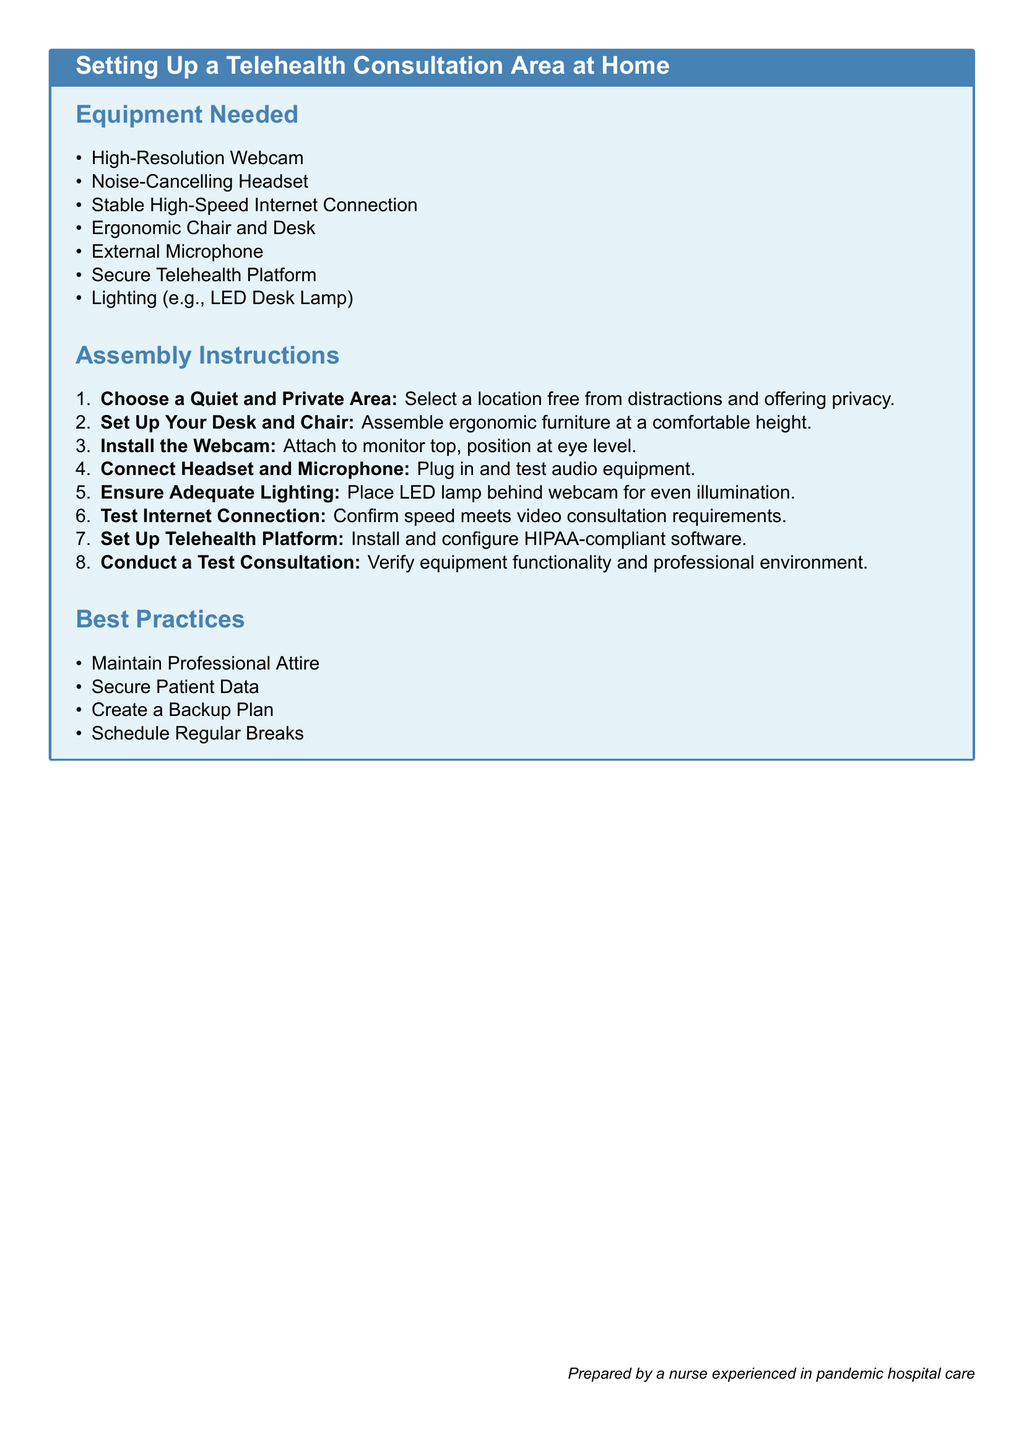what equipment is needed for telehealth consultations? The equipment needed is listed under the "Equipment Needed" section, which includes a High-Resolution Webcam, Noise-Cancelling Headset, and others.
Answer: High-Resolution Webcam, Noise-Cancelling Headset, Stable High-Speed Internet Connection, Ergonomic Chair and Desk, External Microphone, Secure Telehealth Platform, Lighting what is the first step in the assembly instructions? The first step in the assembly instructions is detailed in the "Assembly Instructions" section, where it lists the steps to set up the area.
Answer: Choose a Quiet and Private Area how many types of questions are included in the document? The document has three types of content: Equipment Needed, Assembly Instructions, and Best Practices.
Answer: Three what is the purpose of using a noise-cancelling headset? The purpose of using a noise-cancelling headset relates to the requirements for optimal virtual communication during consultations.
Answer: For audio clarity what should you do after setting up the equipment? The final instruction involves testing the overall setup to ensure everything is working well for consultations.
Answer: Conduct a Test Consultation 